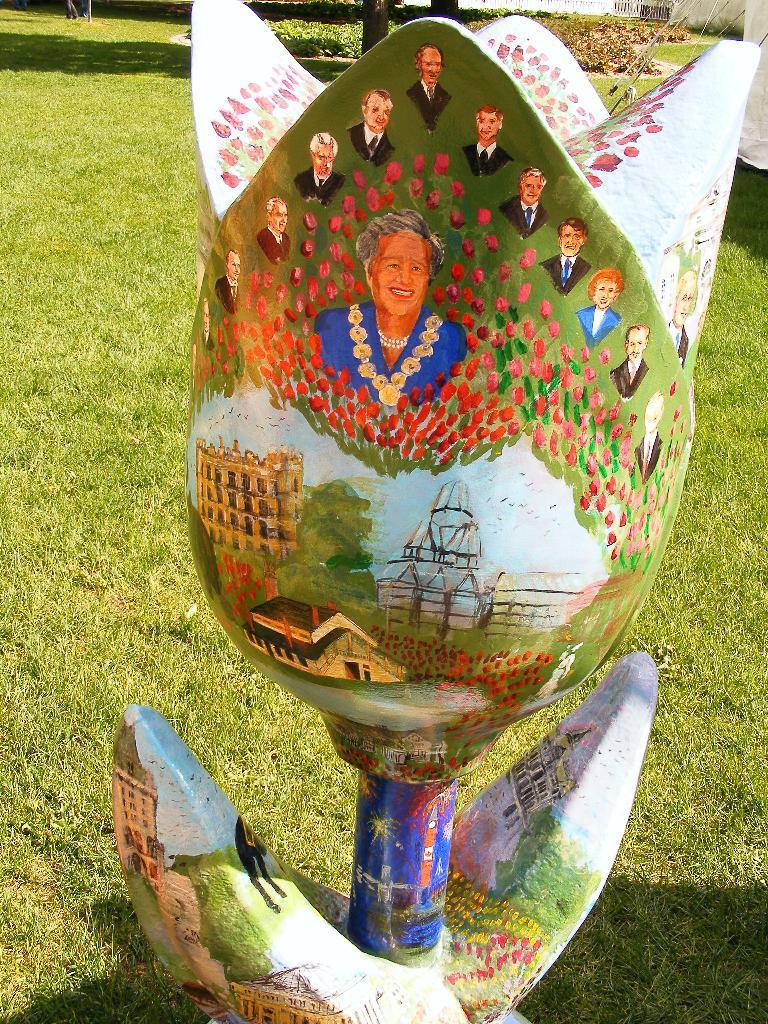How would you summarize this image in a sentence or two? This image consists of an artificial flower. On which we can see a painting. And pictures of few persons. At the bottom, there is green grass. In the background, there are plants. 